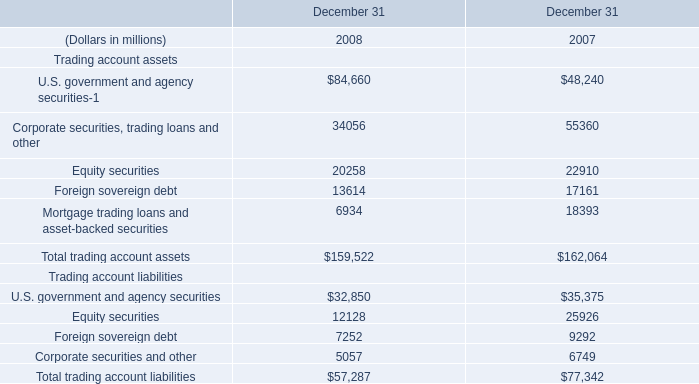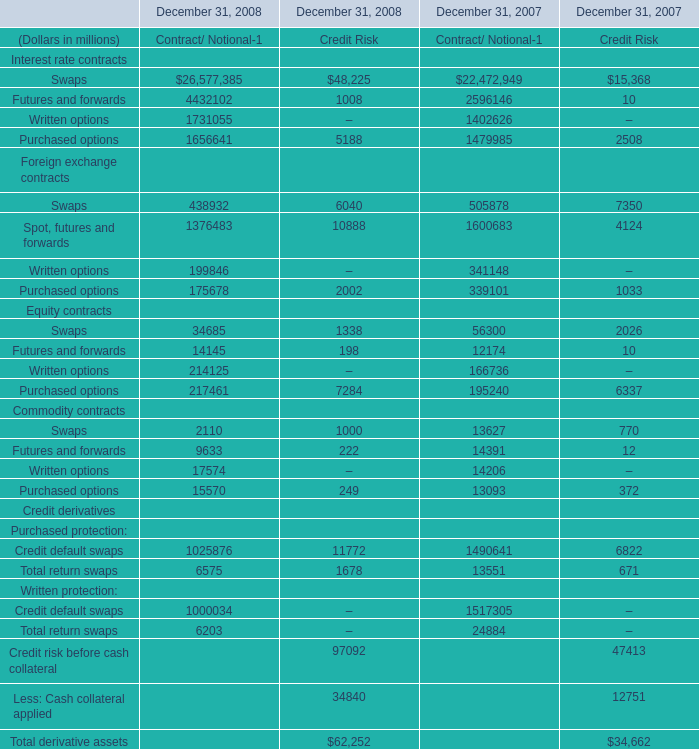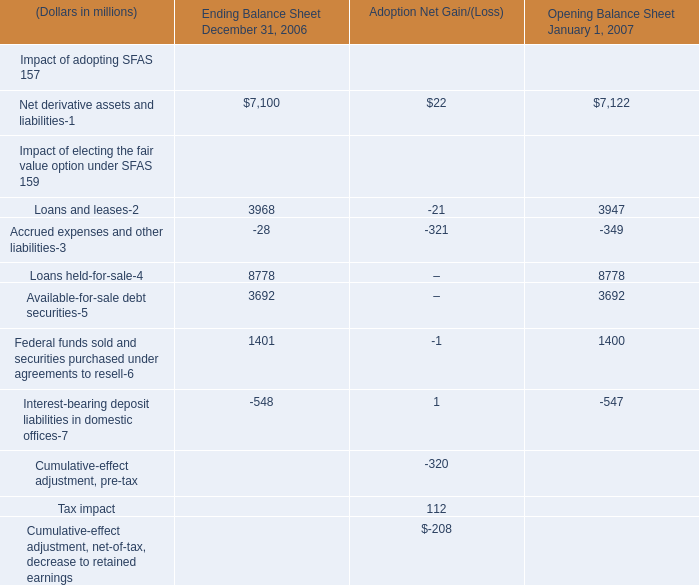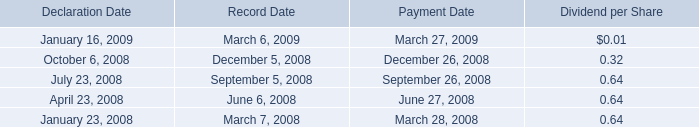What's the average of Foreign sovereign debt of December 31 2007, and Swaps Equity contracts of December 31, 2008 Contract/ Notional ? 
Computations: ((17161.0 + 34685.0) / 2)
Answer: 25923.0. 